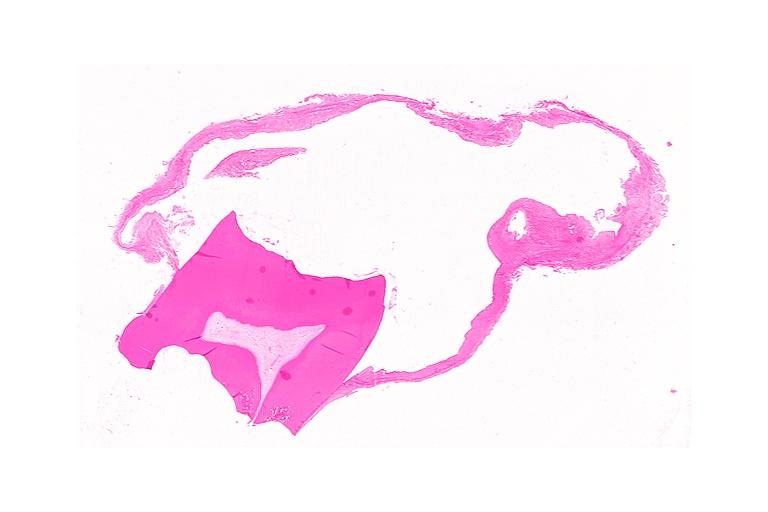what does this image show?
Answer the question using a single word or phrase. Dentigerous cyst 